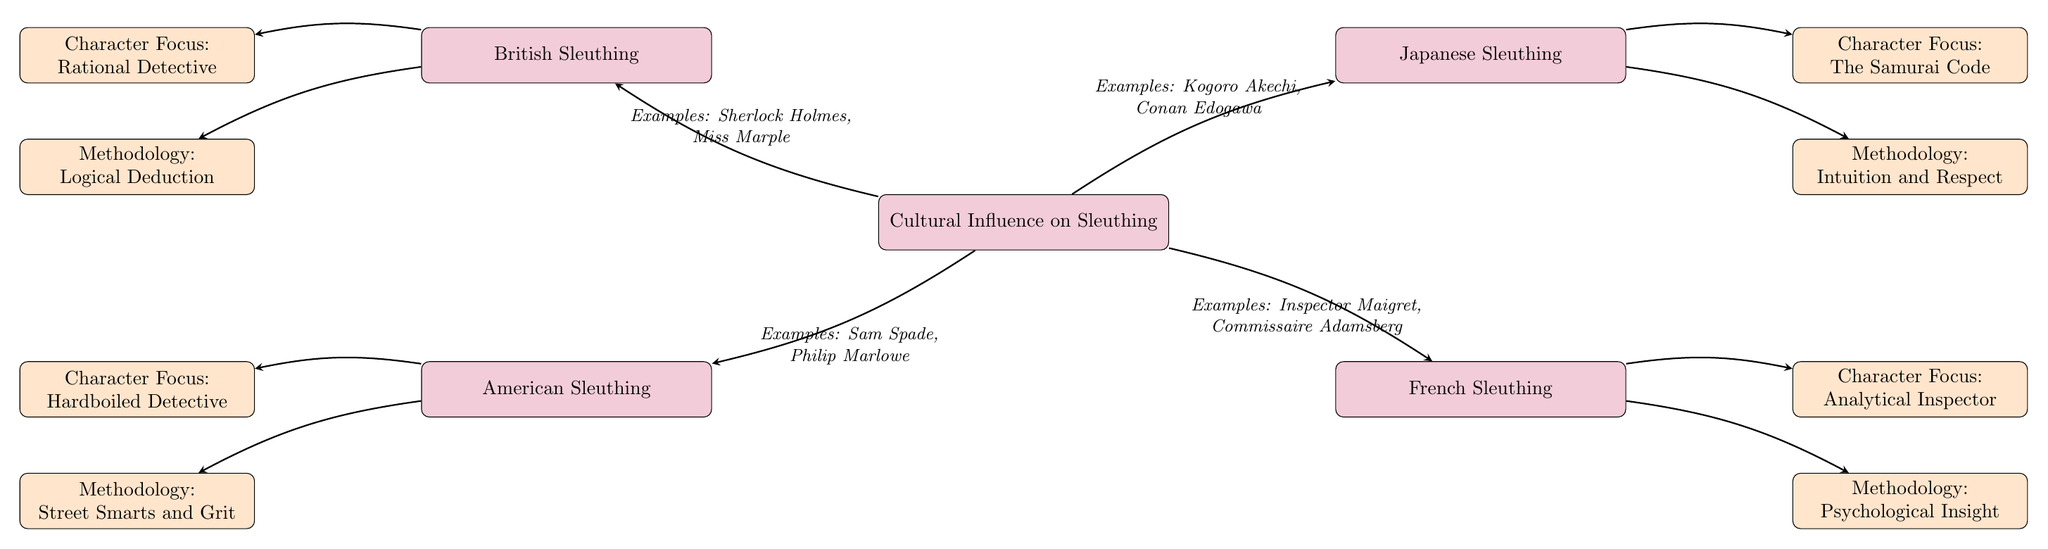What are the four cultural influences on sleuthing depicted in the diagram? The diagram lists four cultural influences on sleuthing, which are British, Japanese, American, and French sleuthing. These are the four main nodes connected to the center node "Cultural Influence on Sleuthing."
Answer: British, Japanese, American, French Which investigation style is associated with the character focus of the "Hardboiled Detective"? The character focus of "Hardboiled Detective" is associated with American sleuthing, which is shown as a sub-node under the American sleuthing node.
Answer: American What methodology is linked to Japanese sleuthing in the diagram? The methodology linked to Japanese sleuthing is "Intuition and Respect," which is a sub-node under the Japanese sleuthing node in the diagram.
Answer: Intuition and Respect How many edges originate from the center node "Cultural Influence on Sleuthing"? There are four edges originating from the center node, each leading to one of the cultural styles: British, Japanese, American, and French.
Answer: Four What does the "Character Focus" of British sleuthing emphasize? The "Character Focus" of British sleuthing emphasizes a "Rational Detective," which is shown as a sub-node under the British sleuthing node in the diagram.
Answer: Rational Detective Which cultural sleuthing style emphasizes "Psychological Insight" as its methodology? "Psychological Insight" is the methodology emphasized by French sleuthing, as indicated by the sub-node under the French sleuthing node.
Answer: French What examples are provided for American sleuthing? The examples provided for American sleuthing are "Sam Spade" and "Philip Marlowe," indicated by the edge connecting American sleuthing to the center node.
Answer: Sam Spade, Philip Marlowe Which sleuthing style incorporates the "Samurai Code" as its character focus? The character focus of "The Samurai Code" is incorporated into Japanese sleuthing, represented as a sub-node under Japanese sleuthing in the diagram.
Answer: Japanese 